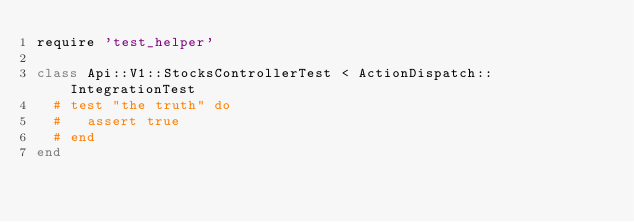<code> <loc_0><loc_0><loc_500><loc_500><_Ruby_>require 'test_helper'

class Api::V1::StocksControllerTest < ActionDispatch::IntegrationTest
  # test "the truth" do
  #   assert true
  # end
end
</code> 